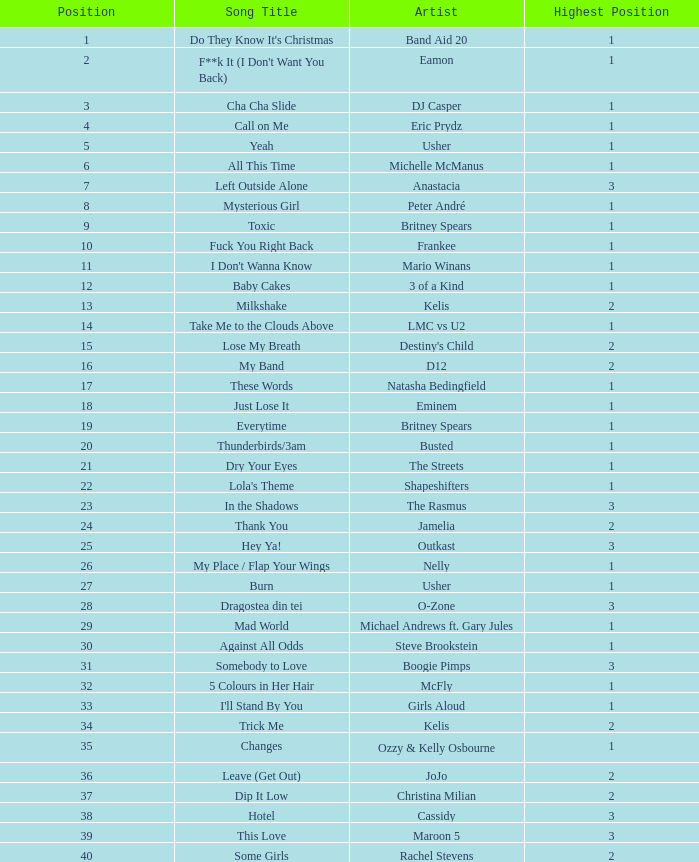What were the revenues for dj casper when he was ranked below 13? 351421.0. 